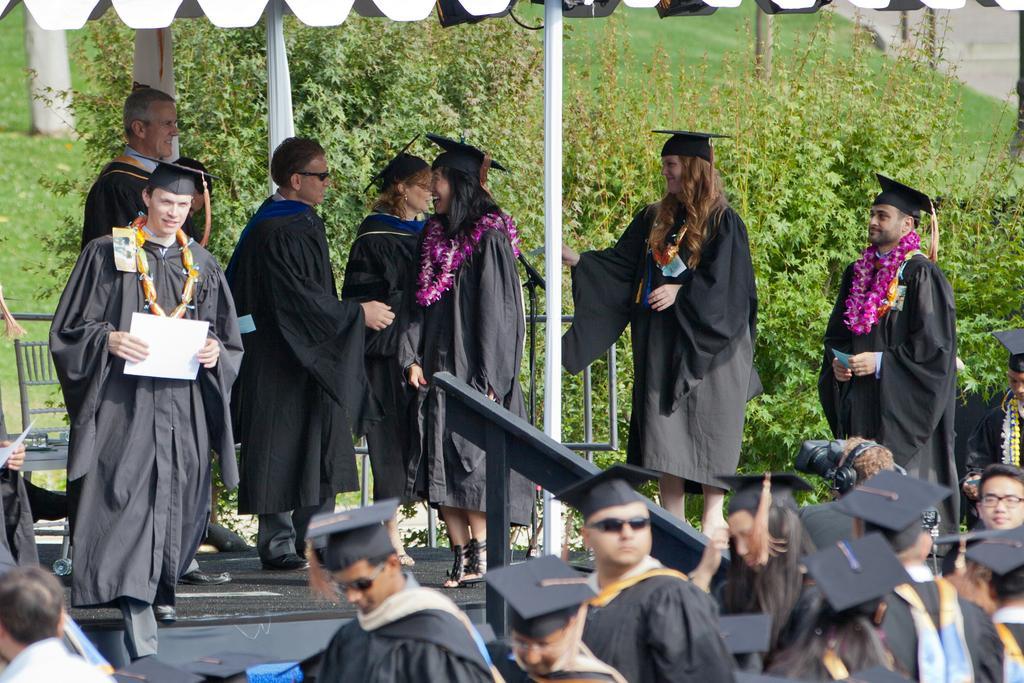In one or two sentences, can you explain what this image depicts? In this picture I can see there is a dais and there are few people standing on the dais and they are wearing graduation dress and the people are holding the certificates. In the backdrop there are plants and trees. 